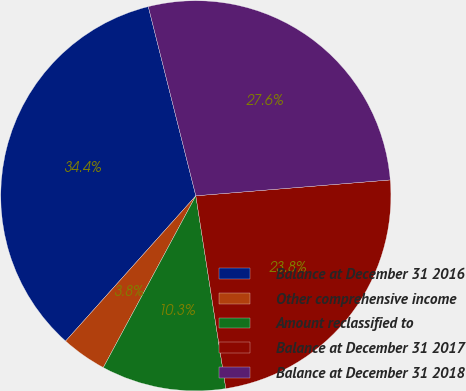Convert chart. <chart><loc_0><loc_0><loc_500><loc_500><pie_chart><fcel>Balance at December 31 2016<fcel>Other comprehensive income<fcel>Amount reclassified to<fcel>Balance at December 31 2017<fcel>Balance at December 31 2018<nl><fcel>34.45%<fcel>3.77%<fcel>10.32%<fcel>23.84%<fcel>27.62%<nl></chart> 